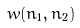<formula> <loc_0><loc_0><loc_500><loc_500>w ( n _ { 1 } , n _ { 2 } )</formula> 